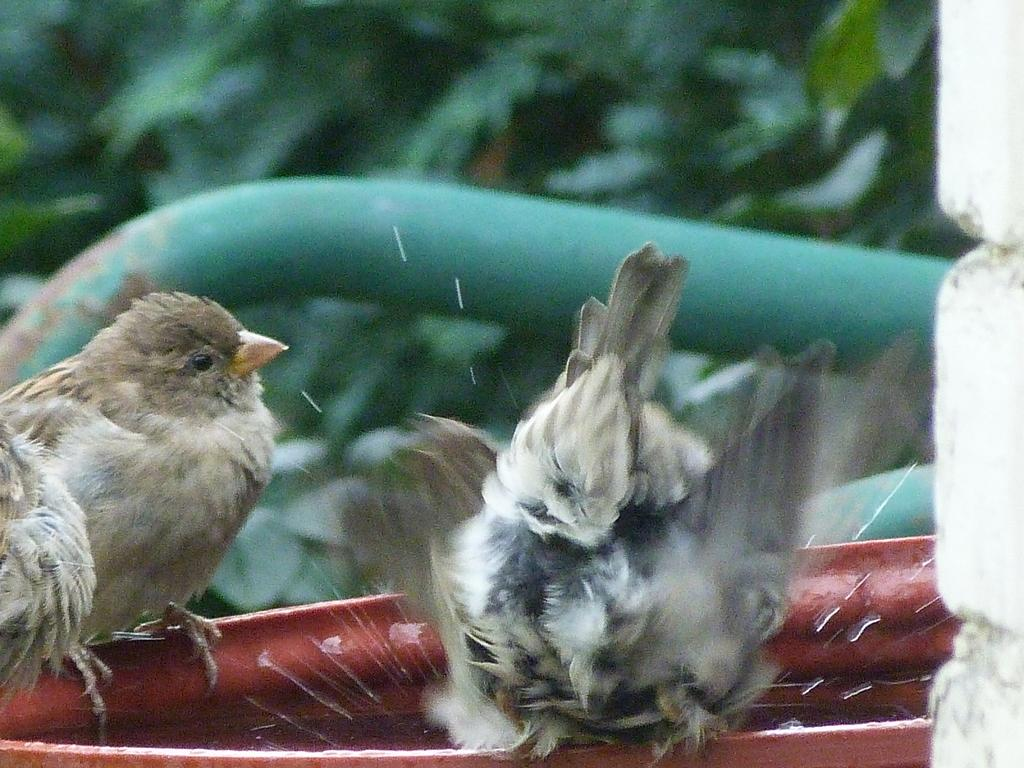What type of animals can be seen in the image? There are birds in the image. Where are the birds located in the image? The birds are standing on an iron rod. What can be seen in the background of the image? There is a tree visible in the image. What type of crime is being committed by the birds in the image? There is no crime being committed by the birds in the image; they are simply standing on an iron rod. Can you tell me how many basketballs are visible in the image? There are no basketballs present in the image. 